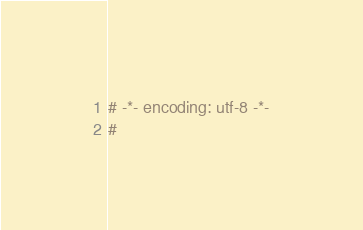Convert code to text. <code><loc_0><loc_0><loc_500><loc_500><_Python_># -*- encoding: utf-8 -*-
#</code> 